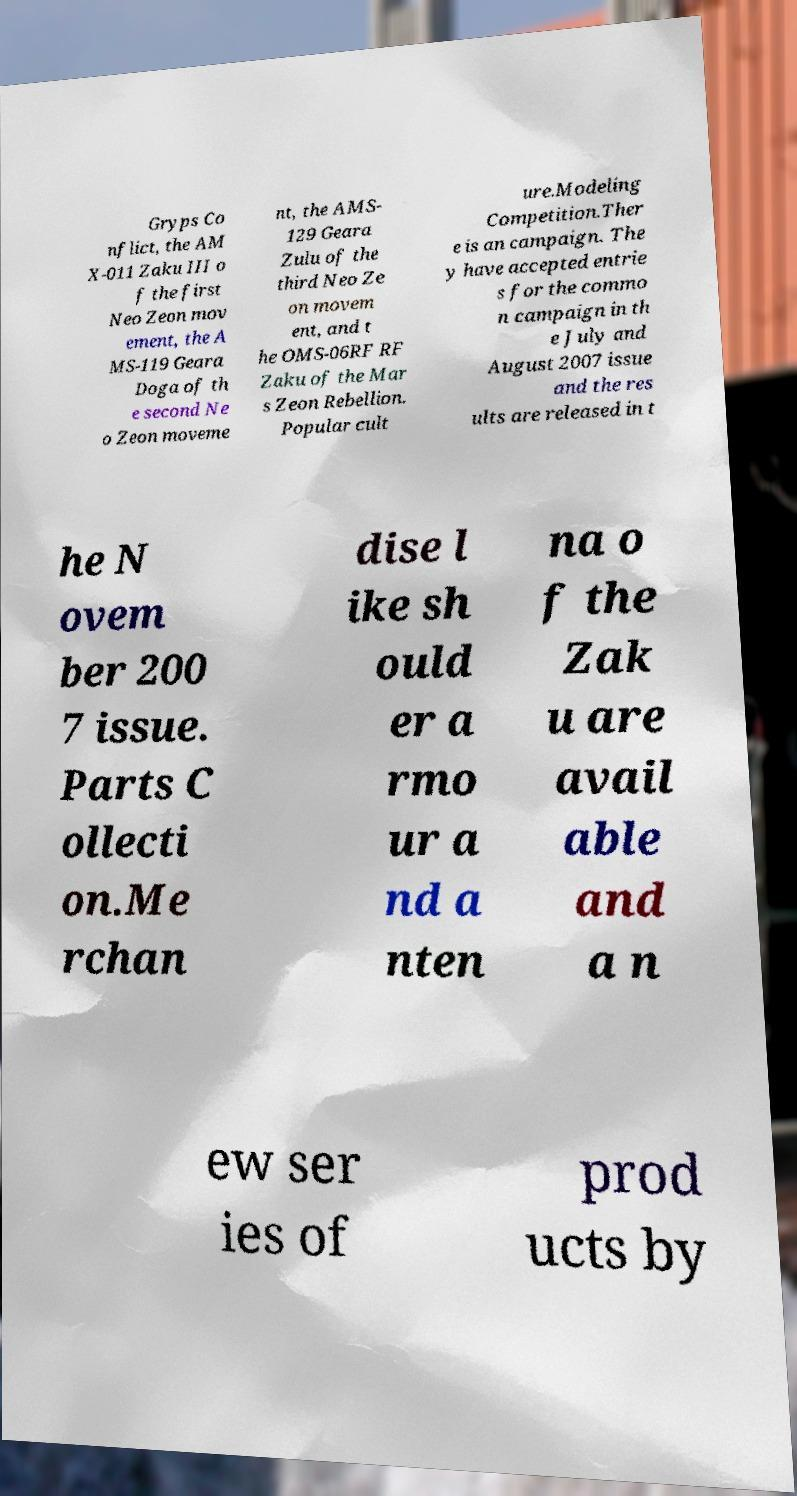Could you assist in decoding the text presented in this image and type it out clearly? Gryps Co nflict, the AM X-011 Zaku III o f the first Neo Zeon mov ement, the A MS-119 Geara Doga of th e second Ne o Zeon moveme nt, the AMS- 129 Geara Zulu of the third Neo Ze on movem ent, and t he OMS-06RF RF Zaku of the Mar s Zeon Rebellion. Popular cult ure.Modeling Competition.Ther e is an campaign. The y have accepted entrie s for the commo n campaign in th e July and August 2007 issue and the res ults are released in t he N ovem ber 200 7 issue. Parts C ollecti on.Me rchan dise l ike sh ould er a rmo ur a nd a nten na o f the Zak u are avail able and a n ew ser ies of prod ucts by 